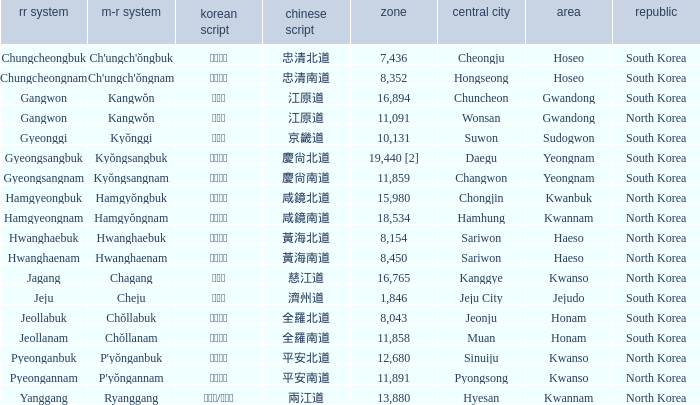What is the area for the province having Hangul of 경기도? 10131.0. 